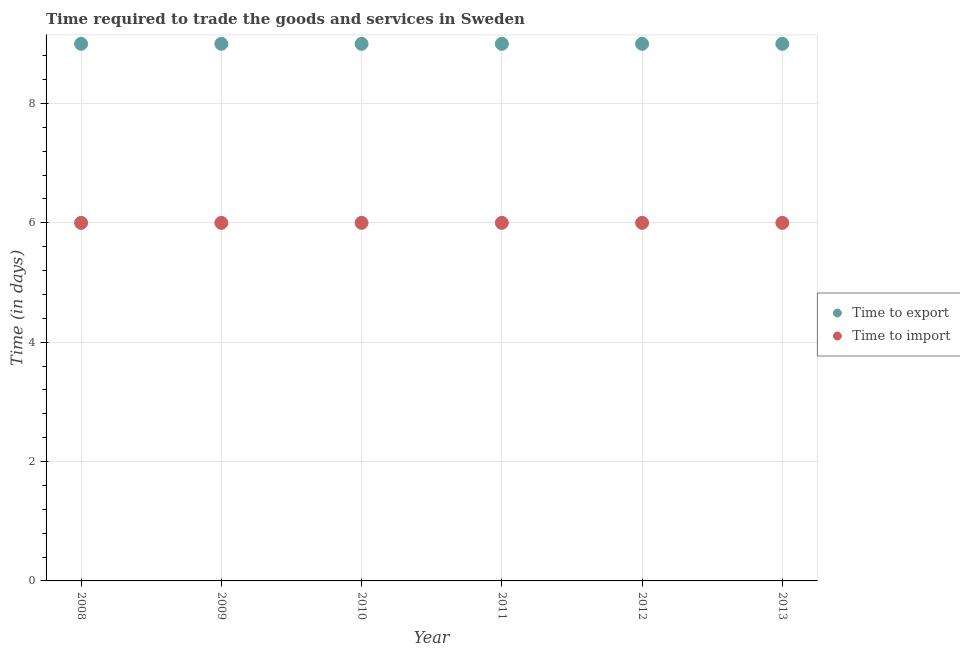How many different coloured dotlines are there?
Ensure brevity in your answer.  2. Is the number of dotlines equal to the number of legend labels?
Your answer should be compact. Yes. Across all years, what is the maximum time to export?
Your answer should be compact. 9. In which year was the time to export minimum?
Your answer should be very brief. 2008. What is the total time to import in the graph?
Ensure brevity in your answer.  36. What is the difference between the time to export in 2010 and the time to import in 2009?
Your answer should be very brief. 3. What is the average time to import per year?
Your response must be concise. 6. In the year 2008, what is the difference between the time to import and time to export?
Your response must be concise. -3. In how many years, is the time to import greater than 0.4 days?
Keep it short and to the point. 6. Is the time to import in 2009 less than that in 2012?
Offer a very short reply. No. Is the difference between the time to import in 2010 and 2011 greater than the difference between the time to export in 2010 and 2011?
Give a very brief answer. No. In how many years, is the time to import greater than the average time to import taken over all years?
Ensure brevity in your answer.  0. Is the sum of the time to import in 2008 and 2011 greater than the maximum time to export across all years?
Give a very brief answer. Yes. Is the time to import strictly greater than the time to export over the years?
Provide a succinct answer. No. How many dotlines are there?
Offer a very short reply. 2. How many years are there in the graph?
Offer a very short reply. 6. Does the graph contain any zero values?
Keep it short and to the point. No. Does the graph contain grids?
Offer a very short reply. Yes. How are the legend labels stacked?
Your response must be concise. Vertical. What is the title of the graph?
Offer a terse response. Time required to trade the goods and services in Sweden. Does "Attending school" appear as one of the legend labels in the graph?
Ensure brevity in your answer.  No. What is the label or title of the X-axis?
Provide a succinct answer. Year. What is the label or title of the Y-axis?
Offer a terse response. Time (in days). What is the Time (in days) of Time to export in 2008?
Give a very brief answer. 9. What is the Time (in days) in Time to export in 2009?
Ensure brevity in your answer.  9. What is the Time (in days) of Time to import in 2009?
Your answer should be compact. 6. What is the Time (in days) of Time to export in 2010?
Give a very brief answer. 9. What is the Time (in days) in Time to export in 2011?
Your answer should be compact. 9. What is the Time (in days) in Time to import in 2011?
Your answer should be very brief. 6. Across all years, what is the maximum Time (in days) in Time to export?
Your answer should be very brief. 9. Across all years, what is the maximum Time (in days) of Time to import?
Keep it short and to the point. 6. Across all years, what is the minimum Time (in days) of Time to import?
Offer a terse response. 6. What is the total Time (in days) in Time to import in the graph?
Provide a succinct answer. 36. What is the difference between the Time (in days) of Time to export in 2008 and that in 2009?
Keep it short and to the point. 0. What is the difference between the Time (in days) in Time to import in 2008 and that in 2010?
Keep it short and to the point. 0. What is the difference between the Time (in days) of Time to export in 2008 and that in 2011?
Provide a short and direct response. 0. What is the difference between the Time (in days) of Time to import in 2008 and that in 2011?
Your answer should be very brief. 0. What is the difference between the Time (in days) in Time to export in 2008 and that in 2012?
Ensure brevity in your answer.  0. What is the difference between the Time (in days) in Time to import in 2008 and that in 2012?
Ensure brevity in your answer.  0. What is the difference between the Time (in days) in Time to import in 2008 and that in 2013?
Provide a succinct answer. 0. What is the difference between the Time (in days) in Time to export in 2009 and that in 2010?
Provide a short and direct response. 0. What is the difference between the Time (in days) of Time to import in 2009 and that in 2011?
Offer a terse response. 0. What is the difference between the Time (in days) in Time to import in 2009 and that in 2012?
Offer a terse response. 0. What is the difference between the Time (in days) in Time to export in 2009 and that in 2013?
Make the answer very short. 0. What is the difference between the Time (in days) of Time to import in 2009 and that in 2013?
Keep it short and to the point. 0. What is the difference between the Time (in days) of Time to import in 2010 and that in 2013?
Ensure brevity in your answer.  0. What is the difference between the Time (in days) of Time to export in 2011 and that in 2012?
Offer a very short reply. 0. What is the difference between the Time (in days) of Time to export in 2012 and that in 2013?
Provide a short and direct response. 0. What is the difference between the Time (in days) in Time to export in 2008 and the Time (in days) in Time to import in 2009?
Keep it short and to the point. 3. What is the difference between the Time (in days) in Time to export in 2008 and the Time (in days) in Time to import in 2012?
Provide a short and direct response. 3. What is the difference between the Time (in days) in Time to export in 2008 and the Time (in days) in Time to import in 2013?
Offer a very short reply. 3. What is the difference between the Time (in days) in Time to export in 2011 and the Time (in days) in Time to import in 2012?
Provide a short and direct response. 3. What is the average Time (in days) of Time to import per year?
Your response must be concise. 6. In the year 2008, what is the difference between the Time (in days) of Time to export and Time (in days) of Time to import?
Your response must be concise. 3. In the year 2009, what is the difference between the Time (in days) in Time to export and Time (in days) in Time to import?
Offer a terse response. 3. In the year 2010, what is the difference between the Time (in days) in Time to export and Time (in days) in Time to import?
Ensure brevity in your answer.  3. In the year 2012, what is the difference between the Time (in days) in Time to export and Time (in days) in Time to import?
Your answer should be very brief. 3. What is the ratio of the Time (in days) of Time to import in 2008 to that in 2010?
Provide a succinct answer. 1. What is the ratio of the Time (in days) in Time to export in 2008 to that in 2011?
Provide a succinct answer. 1. What is the ratio of the Time (in days) of Time to import in 2008 to that in 2011?
Ensure brevity in your answer.  1. What is the ratio of the Time (in days) in Time to export in 2008 to that in 2013?
Ensure brevity in your answer.  1. What is the ratio of the Time (in days) in Time to import in 2008 to that in 2013?
Make the answer very short. 1. What is the ratio of the Time (in days) of Time to export in 2009 to that in 2010?
Offer a terse response. 1. What is the ratio of the Time (in days) in Time to import in 2009 to that in 2010?
Make the answer very short. 1. What is the ratio of the Time (in days) in Time to import in 2009 to that in 2011?
Make the answer very short. 1. What is the ratio of the Time (in days) of Time to export in 2009 to that in 2012?
Provide a succinct answer. 1. What is the ratio of the Time (in days) of Time to import in 2009 to that in 2012?
Offer a terse response. 1. What is the ratio of the Time (in days) of Time to export in 2009 to that in 2013?
Your answer should be very brief. 1. What is the ratio of the Time (in days) in Time to import in 2009 to that in 2013?
Provide a succinct answer. 1. What is the ratio of the Time (in days) in Time to export in 2010 to that in 2011?
Make the answer very short. 1. What is the ratio of the Time (in days) in Time to export in 2010 to that in 2012?
Give a very brief answer. 1. What is the ratio of the Time (in days) of Time to export in 2010 to that in 2013?
Ensure brevity in your answer.  1. What is the ratio of the Time (in days) of Time to import in 2010 to that in 2013?
Your answer should be very brief. 1. What is the ratio of the Time (in days) of Time to import in 2011 to that in 2012?
Give a very brief answer. 1. What is the ratio of the Time (in days) in Time to export in 2011 to that in 2013?
Provide a succinct answer. 1. What is the ratio of the Time (in days) of Time to import in 2011 to that in 2013?
Provide a short and direct response. 1. What is the ratio of the Time (in days) of Time to export in 2012 to that in 2013?
Provide a short and direct response. 1. What is the ratio of the Time (in days) of Time to import in 2012 to that in 2013?
Offer a terse response. 1. What is the difference between the highest and the second highest Time (in days) of Time to export?
Offer a very short reply. 0. What is the difference between the highest and the second highest Time (in days) of Time to import?
Provide a short and direct response. 0. What is the difference between the highest and the lowest Time (in days) in Time to import?
Provide a succinct answer. 0. 